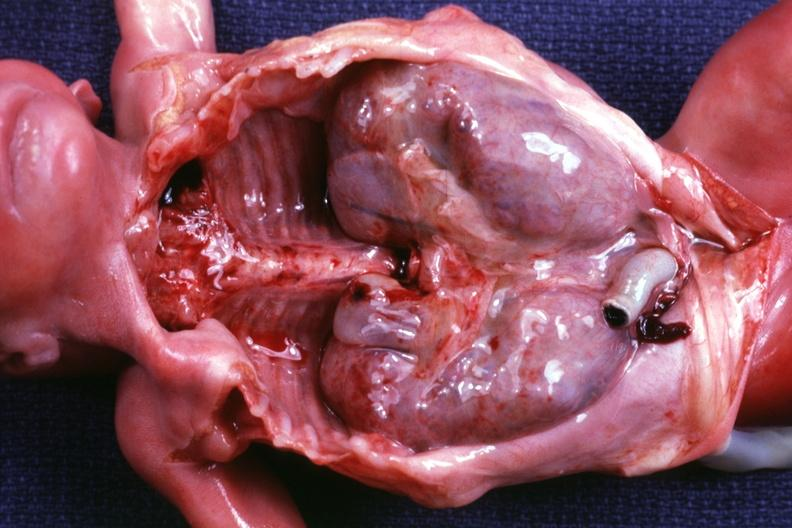s red perifollicular amyloid deposits removed dramatic demonstration of size of kidneys?
Answer the question using a single word or phrase. No 